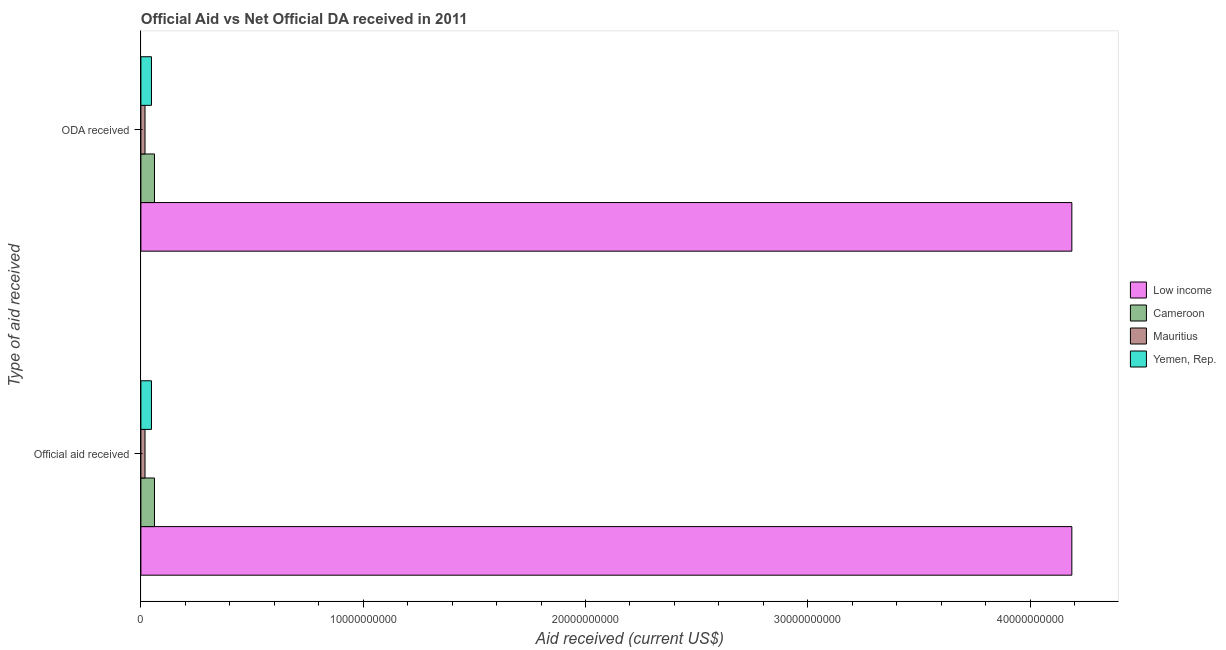Are the number of bars per tick equal to the number of legend labels?
Your answer should be compact. Yes. Are the number of bars on each tick of the Y-axis equal?
Your answer should be very brief. Yes. How many bars are there on the 1st tick from the top?
Your response must be concise. 4. How many bars are there on the 2nd tick from the bottom?
Provide a succinct answer. 4. What is the label of the 2nd group of bars from the top?
Make the answer very short. Official aid received. What is the official aid received in Cameroon?
Provide a succinct answer. 6.12e+08. Across all countries, what is the maximum oda received?
Offer a very short reply. 4.19e+1. Across all countries, what is the minimum oda received?
Offer a very short reply. 1.85e+08. In which country was the official aid received maximum?
Keep it short and to the point. Low income. In which country was the official aid received minimum?
Your response must be concise. Mauritius. What is the total oda received in the graph?
Keep it short and to the point. 4.32e+1. What is the difference between the official aid received in Mauritius and that in Yemen, Rep.?
Offer a terse response. -2.91e+08. What is the difference between the official aid received in Mauritius and the oda received in Cameroon?
Keep it short and to the point. -4.27e+08. What is the average oda received per country?
Keep it short and to the point. 1.08e+1. What is the ratio of the official aid received in Yemen, Rep. to that in Mauritius?
Provide a short and direct response. 2.57. In how many countries, is the official aid received greater than the average official aid received taken over all countries?
Your response must be concise. 1. What does the 2nd bar from the top in Official aid received represents?
Provide a short and direct response. Mauritius. What does the 4th bar from the bottom in Official aid received represents?
Offer a terse response. Yemen, Rep. How many bars are there?
Make the answer very short. 8. Are all the bars in the graph horizontal?
Offer a terse response. Yes. What is the difference between two consecutive major ticks on the X-axis?
Your response must be concise. 1.00e+1. Are the values on the major ticks of X-axis written in scientific E-notation?
Provide a succinct answer. No. How many legend labels are there?
Ensure brevity in your answer.  4. How are the legend labels stacked?
Make the answer very short. Vertical. What is the title of the graph?
Provide a succinct answer. Official Aid vs Net Official DA received in 2011 . Does "St. Martin (French part)" appear as one of the legend labels in the graph?
Your answer should be compact. No. What is the label or title of the X-axis?
Offer a terse response. Aid received (current US$). What is the label or title of the Y-axis?
Offer a very short reply. Type of aid received. What is the Aid received (current US$) in Low income in Official aid received?
Offer a terse response. 4.19e+1. What is the Aid received (current US$) in Cameroon in Official aid received?
Provide a short and direct response. 6.12e+08. What is the Aid received (current US$) of Mauritius in Official aid received?
Provide a short and direct response. 1.85e+08. What is the Aid received (current US$) in Yemen, Rep. in Official aid received?
Your response must be concise. 4.76e+08. What is the Aid received (current US$) in Low income in ODA received?
Your response must be concise. 4.19e+1. What is the Aid received (current US$) in Cameroon in ODA received?
Offer a very short reply. 6.12e+08. What is the Aid received (current US$) of Mauritius in ODA received?
Provide a succinct answer. 1.85e+08. What is the Aid received (current US$) in Yemen, Rep. in ODA received?
Ensure brevity in your answer.  4.76e+08. Across all Type of aid received, what is the maximum Aid received (current US$) of Low income?
Make the answer very short. 4.19e+1. Across all Type of aid received, what is the maximum Aid received (current US$) in Cameroon?
Provide a succinct answer. 6.12e+08. Across all Type of aid received, what is the maximum Aid received (current US$) of Mauritius?
Provide a succinct answer. 1.85e+08. Across all Type of aid received, what is the maximum Aid received (current US$) in Yemen, Rep.?
Offer a terse response. 4.76e+08. Across all Type of aid received, what is the minimum Aid received (current US$) of Low income?
Provide a succinct answer. 4.19e+1. Across all Type of aid received, what is the minimum Aid received (current US$) of Cameroon?
Offer a terse response. 6.12e+08. Across all Type of aid received, what is the minimum Aid received (current US$) of Mauritius?
Give a very brief answer. 1.85e+08. Across all Type of aid received, what is the minimum Aid received (current US$) of Yemen, Rep.?
Offer a terse response. 4.76e+08. What is the total Aid received (current US$) in Low income in the graph?
Your answer should be very brief. 8.38e+1. What is the total Aid received (current US$) of Cameroon in the graph?
Your answer should be compact. 1.22e+09. What is the total Aid received (current US$) in Mauritius in the graph?
Offer a terse response. 3.71e+08. What is the total Aid received (current US$) in Yemen, Rep. in the graph?
Provide a succinct answer. 9.52e+08. What is the difference between the Aid received (current US$) of Low income in Official aid received and that in ODA received?
Offer a terse response. 0. What is the difference between the Aid received (current US$) of Yemen, Rep. in Official aid received and that in ODA received?
Your answer should be very brief. 0. What is the difference between the Aid received (current US$) of Low income in Official aid received and the Aid received (current US$) of Cameroon in ODA received?
Provide a succinct answer. 4.13e+1. What is the difference between the Aid received (current US$) of Low income in Official aid received and the Aid received (current US$) of Mauritius in ODA received?
Give a very brief answer. 4.17e+1. What is the difference between the Aid received (current US$) of Low income in Official aid received and the Aid received (current US$) of Yemen, Rep. in ODA received?
Provide a short and direct response. 4.14e+1. What is the difference between the Aid received (current US$) of Cameroon in Official aid received and the Aid received (current US$) of Mauritius in ODA received?
Provide a succinct answer. 4.27e+08. What is the difference between the Aid received (current US$) of Cameroon in Official aid received and the Aid received (current US$) of Yemen, Rep. in ODA received?
Keep it short and to the point. 1.36e+08. What is the difference between the Aid received (current US$) in Mauritius in Official aid received and the Aid received (current US$) in Yemen, Rep. in ODA received?
Your answer should be very brief. -2.91e+08. What is the average Aid received (current US$) of Low income per Type of aid received?
Make the answer very short. 4.19e+1. What is the average Aid received (current US$) in Cameroon per Type of aid received?
Provide a succinct answer. 6.12e+08. What is the average Aid received (current US$) of Mauritius per Type of aid received?
Your answer should be very brief. 1.85e+08. What is the average Aid received (current US$) in Yemen, Rep. per Type of aid received?
Your answer should be very brief. 4.76e+08. What is the difference between the Aid received (current US$) in Low income and Aid received (current US$) in Cameroon in Official aid received?
Give a very brief answer. 4.13e+1. What is the difference between the Aid received (current US$) of Low income and Aid received (current US$) of Mauritius in Official aid received?
Offer a terse response. 4.17e+1. What is the difference between the Aid received (current US$) in Low income and Aid received (current US$) in Yemen, Rep. in Official aid received?
Provide a short and direct response. 4.14e+1. What is the difference between the Aid received (current US$) of Cameroon and Aid received (current US$) of Mauritius in Official aid received?
Offer a very short reply. 4.27e+08. What is the difference between the Aid received (current US$) of Cameroon and Aid received (current US$) of Yemen, Rep. in Official aid received?
Give a very brief answer. 1.36e+08. What is the difference between the Aid received (current US$) in Mauritius and Aid received (current US$) in Yemen, Rep. in Official aid received?
Ensure brevity in your answer.  -2.91e+08. What is the difference between the Aid received (current US$) of Low income and Aid received (current US$) of Cameroon in ODA received?
Make the answer very short. 4.13e+1. What is the difference between the Aid received (current US$) in Low income and Aid received (current US$) in Mauritius in ODA received?
Offer a very short reply. 4.17e+1. What is the difference between the Aid received (current US$) in Low income and Aid received (current US$) in Yemen, Rep. in ODA received?
Offer a very short reply. 4.14e+1. What is the difference between the Aid received (current US$) in Cameroon and Aid received (current US$) in Mauritius in ODA received?
Provide a succinct answer. 4.27e+08. What is the difference between the Aid received (current US$) of Cameroon and Aid received (current US$) of Yemen, Rep. in ODA received?
Offer a terse response. 1.36e+08. What is the difference between the Aid received (current US$) of Mauritius and Aid received (current US$) of Yemen, Rep. in ODA received?
Offer a terse response. -2.91e+08. What is the ratio of the Aid received (current US$) in Low income in Official aid received to that in ODA received?
Offer a very short reply. 1. What is the difference between the highest and the second highest Aid received (current US$) of Yemen, Rep.?
Your response must be concise. 0. What is the difference between the highest and the lowest Aid received (current US$) of Cameroon?
Make the answer very short. 0. What is the difference between the highest and the lowest Aid received (current US$) of Yemen, Rep.?
Provide a succinct answer. 0. 